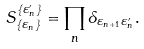Convert formula to latex. <formula><loc_0><loc_0><loc_500><loc_500>S ^ { \{ \varepsilon ^ { \prime } _ { n } \} } _ { \{ \varepsilon _ { n } \} } = \prod _ { n } \delta _ { \varepsilon _ { n + 1 } \varepsilon ^ { \prime } _ { n } } .</formula> 